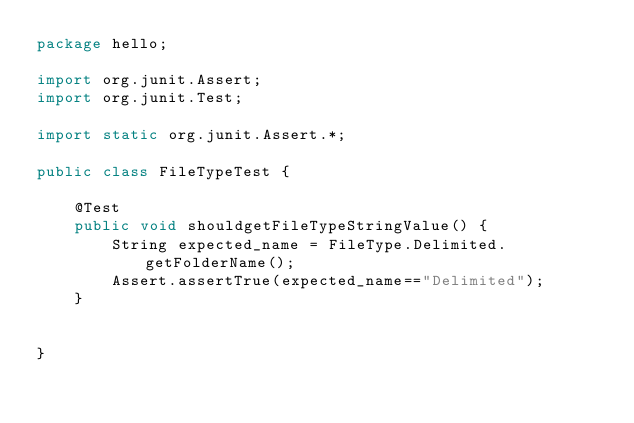Convert code to text. <code><loc_0><loc_0><loc_500><loc_500><_Java_>package hello;

import org.junit.Assert;
import org.junit.Test;

import static org.junit.Assert.*;

public class FileTypeTest {

    @Test
    public void shouldgetFileTypeStringValue() {
        String expected_name = FileType.Delimited.getFolderName();
        Assert.assertTrue(expected_name=="Delimited");
    }


}</code> 